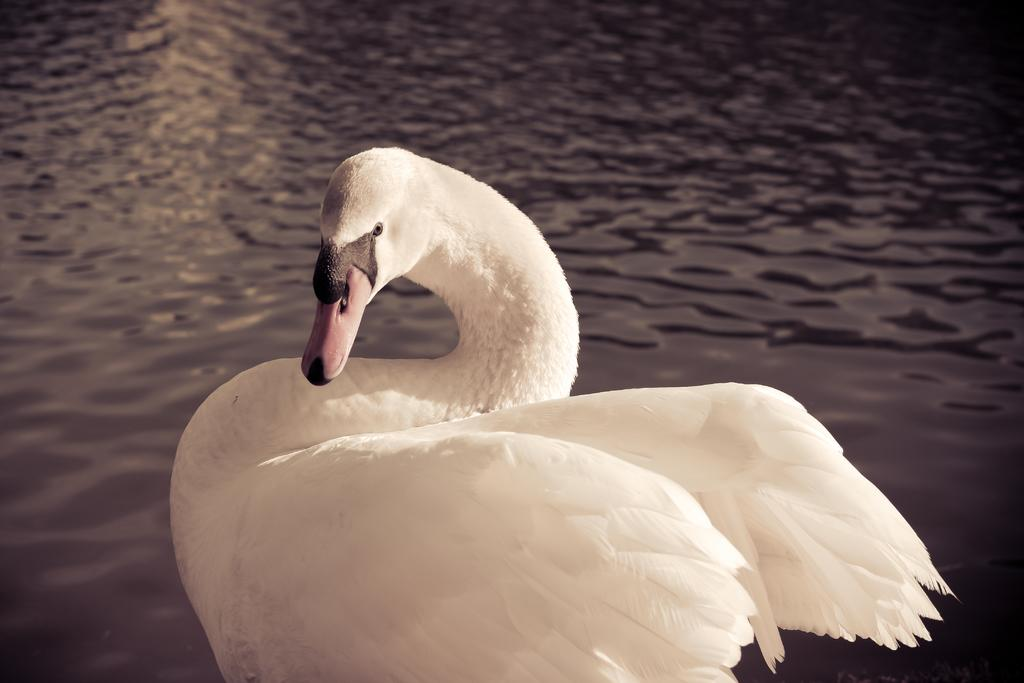What structure is visible in the image? There is a dock in the image. What type of water body can be seen in the background? There is a river in the background of the image. How many goldfish are swimming in the river in the image? There are no goldfish visible in the image; it only shows a dock and a river in the background. 